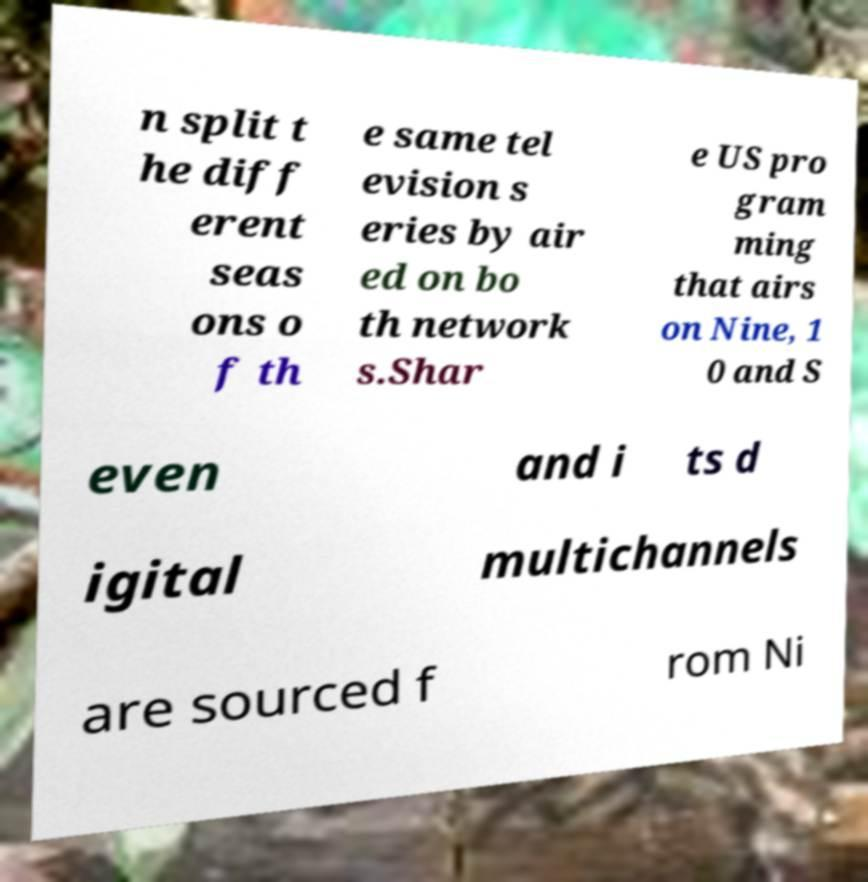There's text embedded in this image that I need extracted. Can you transcribe it verbatim? n split t he diff erent seas ons o f th e same tel evision s eries by air ed on bo th network s.Shar e US pro gram ming that airs on Nine, 1 0 and S even and i ts d igital multichannels are sourced f rom Ni 